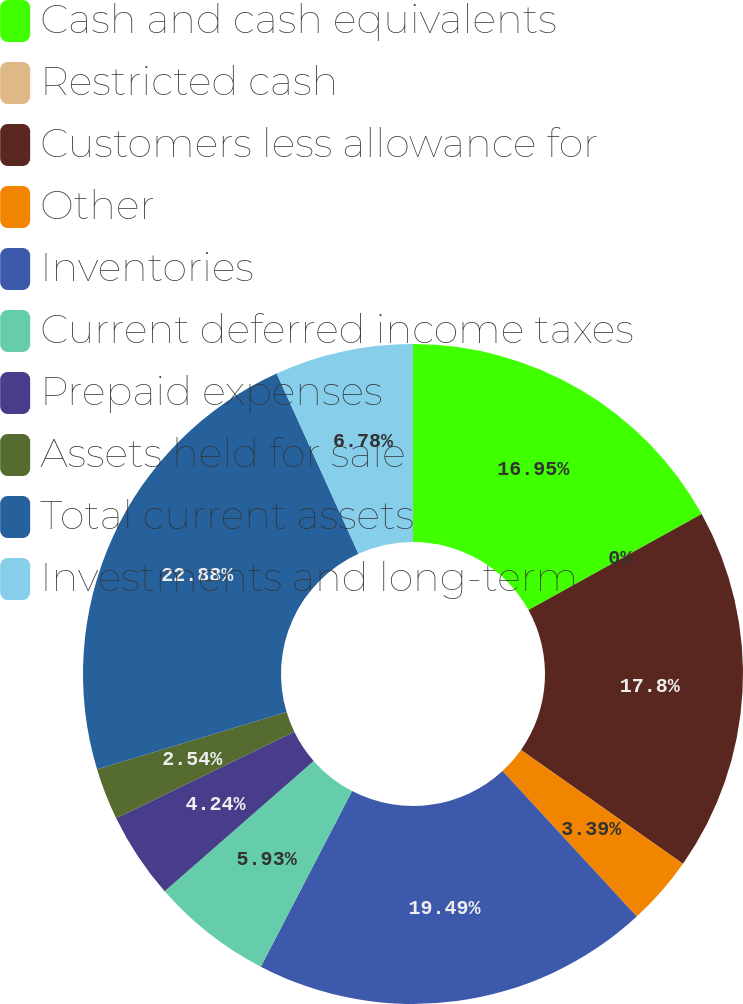<chart> <loc_0><loc_0><loc_500><loc_500><pie_chart><fcel>Cash and cash equivalents<fcel>Restricted cash<fcel>Customers less allowance for<fcel>Other<fcel>Inventories<fcel>Current deferred income taxes<fcel>Prepaid expenses<fcel>Assets held for sale<fcel>Total current assets<fcel>Investments and long-term<nl><fcel>16.95%<fcel>0.0%<fcel>17.8%<fcel>3.39%<fcel>19.49%<fcel>5.93%<fcel>4.24%<fcel>2.54%<fcel>22.88%<fcel>6.78%<nl></chart> 